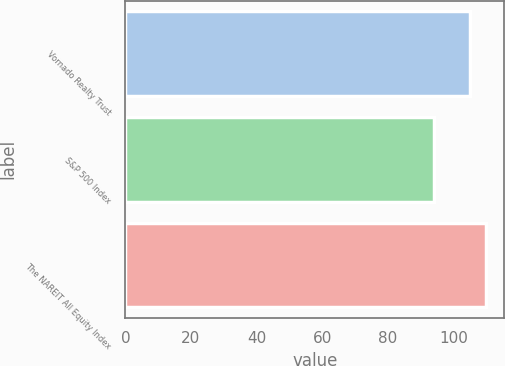Convert chart to OTSL. <chart><loc_0><loc_0><loc_500><loc_500><bar_chart><fcel>Vornado Realty Trust<fcel>S&P 500 Index<fcel>The NAREIT All Equity Index<nl><fcel>105<fcel>94<fcel>110<nl></chart> 